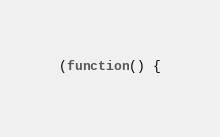<code> <loc_0><loc_0><loc_500><loc_500><_JavaScript_>(function() {</code> 